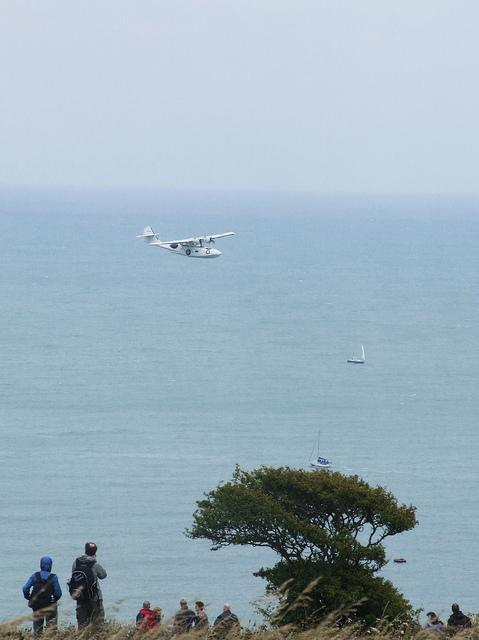Which thing here is the highest? plane 